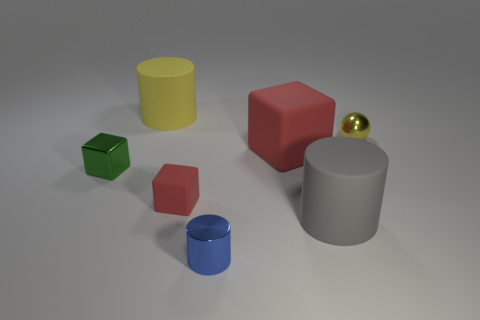Add 1 small metallic things. How many objects exist? 8 Subtract all blocks. How many objects are left? 4 Subtract all small shiny cylinders. Subtract all gray rubber cylinders. How many objects are left? 5 Add 4 small red blocks. How many small red blocks are left? 5 Add 3 tiny red things. How many tiny red things exist? 4 Subtract 1 blue cylinders. How many objects are left? 6 